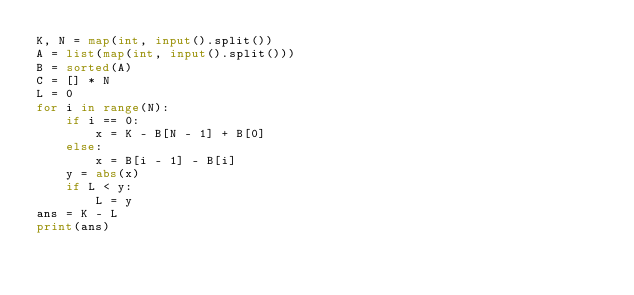<code> <loc_0><loc_0><loc_500><loc_500><_Python_>K, N = map(int, input().split())
A = list(map(int, input().split()))
B = sorted(A)
C = [] * N
L = 0
for i in range(N):
    if i == 0:
        x = K - B[N - 1] + B[0]
    else:
        x = B[i - 1] - B[i]
    y = abs(x)
    if L < y:
        L = y
ans = K - L
print(ans)</code> 